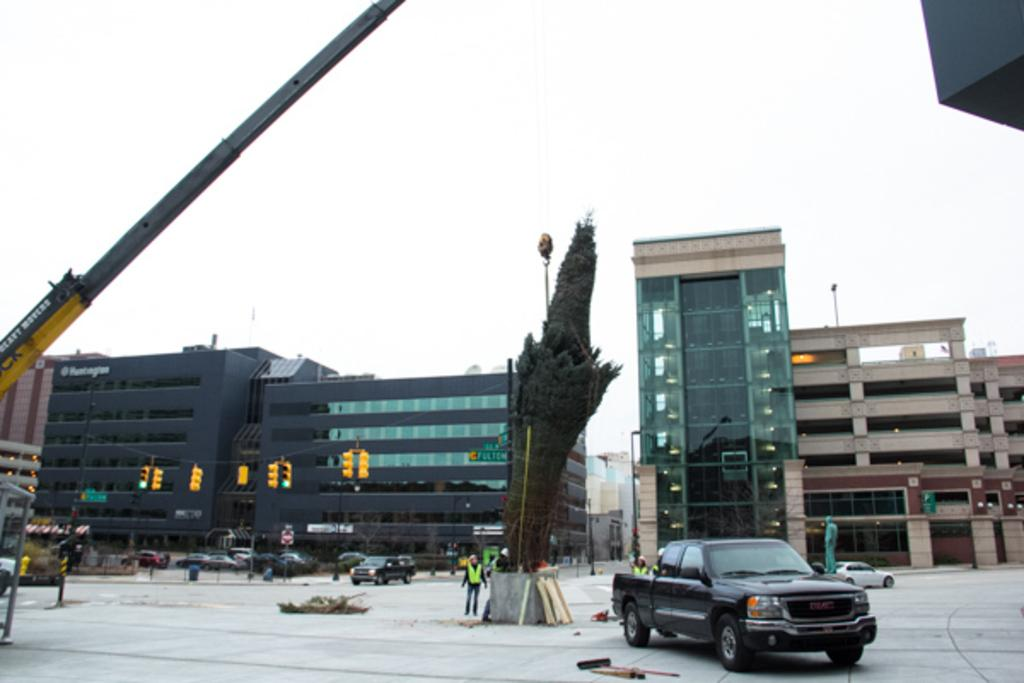What is located in the center of the image? There are buildings, signals, cars, and people in the center of the image. What can be seen in the foreground of the image? There is wood material, a tree crane, and a car in the foreground of the image. What is the condition of the sky in the image? The sky is cloudy in the image. What type of meat is being served in the image? There is no meat present in the image; it features buildings, signals, cars, people, wood material, a tree crane, and a car. What color are the trucks in the image? There are no trucks present in the image. 